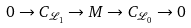<formula> <loc_0><loc_0><loc_500><loc_500>0 \to C _ { \mathcal { L } _ { 1 } } \to M \to C _ { \mathcal { L } _ { 0 } } \to 0</formula> 